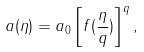<formula> <loc_0><loc_0><loc_500><loc_500>a ( \eta ) = a _ { 0 } \left [ f ( { \frac { \eta } { q } } ) \right ] ^ { q } ,</formula> 